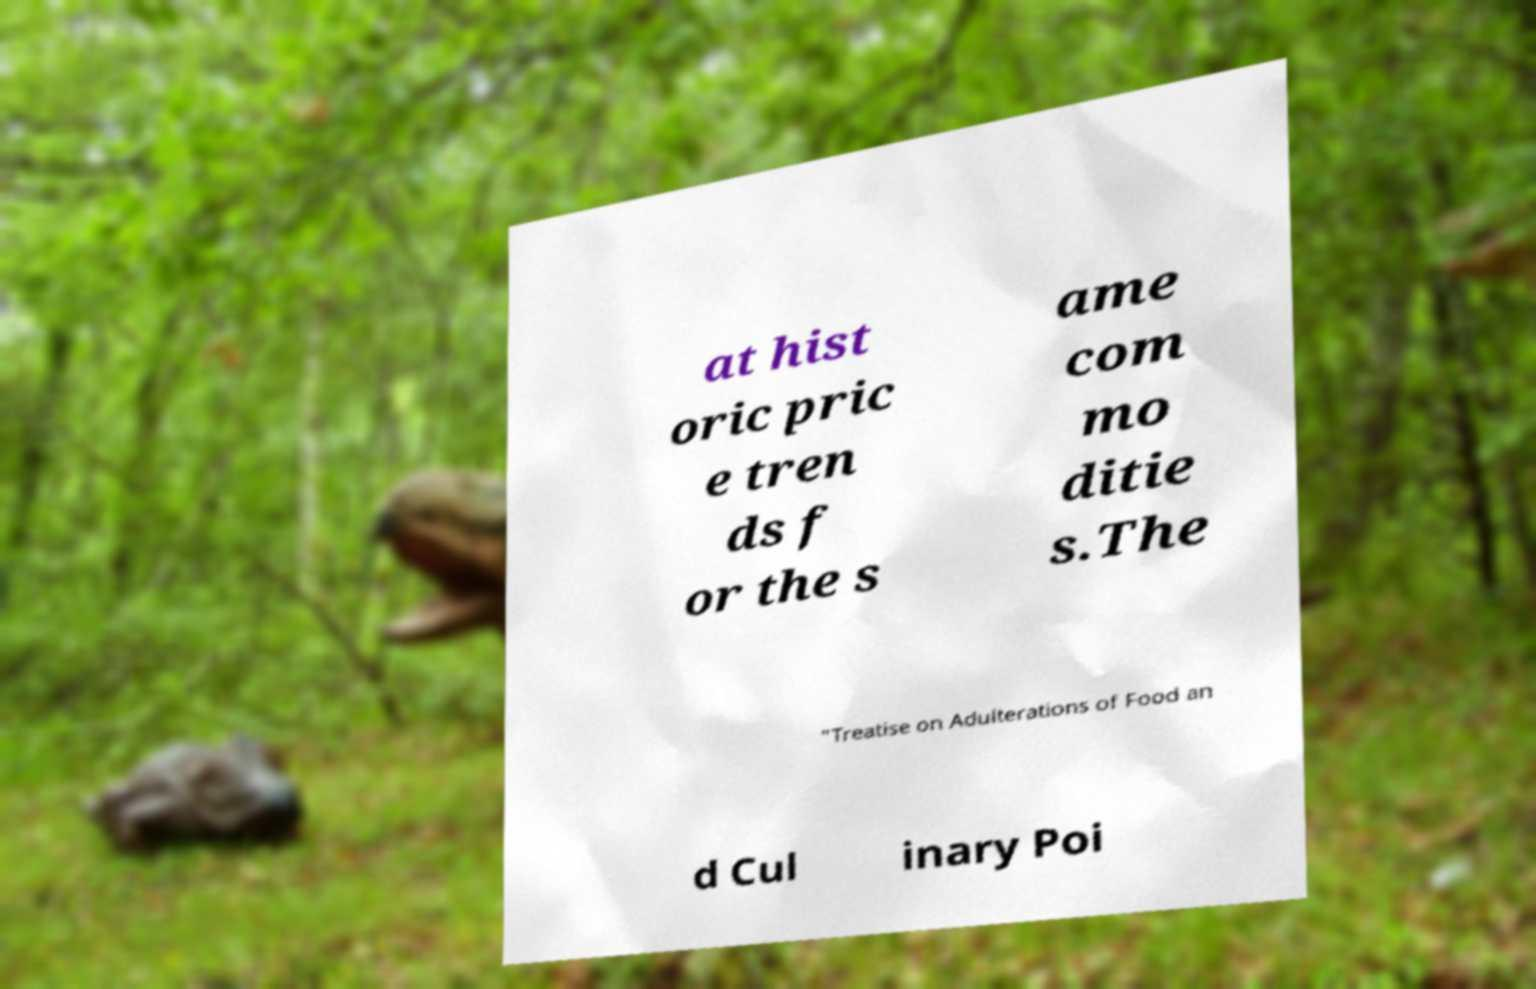Please read and relay the text visible in this image. What does it say? at hist oric pric e tren ds f or the s ame com mo ditie s.The "Treatise on Adulterations of Food an d Cul inary Poi 